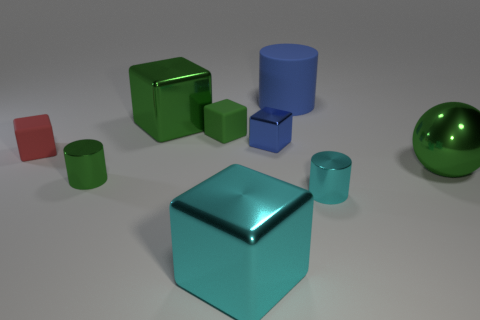How would you describe the lighting in the scene and the shadows created by the objects? The lighting in the scene is diffused and soft, likely from an overhead source, as suggested by the subtle shadows cast directly underneath the objects. These shadows help provide depth and a sense of space, enhancing the three-dimensional appearance of the scene. 